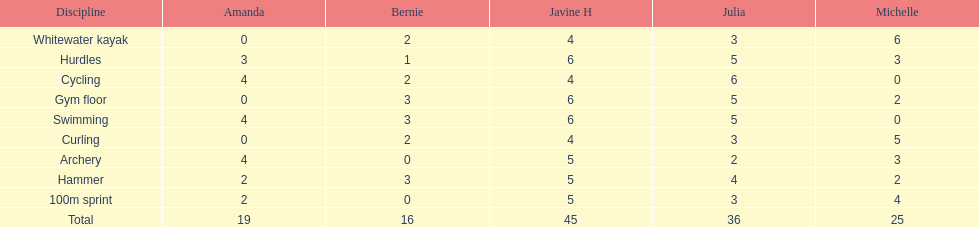What is the average score on 100m sprint? 2.8. 